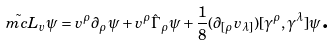Convert formula to latex. <formula><loc_0><loc_0><loc_500><loc_500>\tilde { \ m c L } _ { v } \psi = v ^ { \rho } \partial _ { \rho } \psi + v ^ { \rho } \hat { \Gamma } _ { \rho } \psi + \frac { 1 } { 8 } ( \partial _ { [ \rho } v _ { \lambda ] } ) [ \gamma ^ { \rho } , \gamma ^ { \lambda } ] \psi \text {.}</formula> 